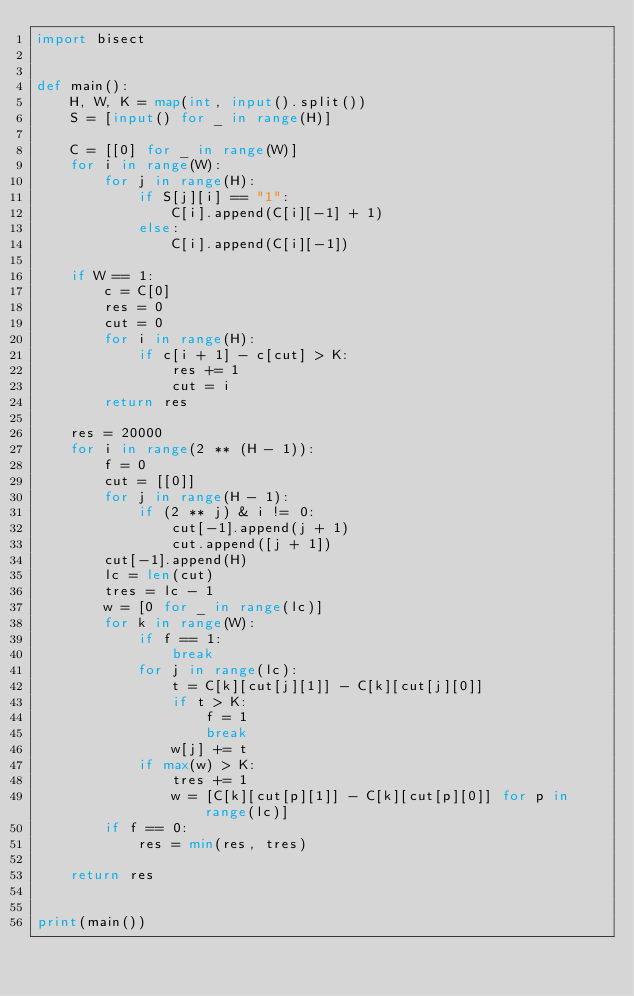<code> <loc_0><loc_0><loc_500><loc_500><_Python_>import bisect


def main():
    H, W, K = map(int, input().split())
    S = [input() for _ in range(H)]

    C = [[0] for _ in range(W)]
    for i in range(W):
        for j in range(H):
            if S[j][i] == "1":
                C[i].append(C[i][-1] + 1)
            else:
                C[i].append(C[i][-1])

    if W == 1:
        c = C[0]
        res = 0
        cut = 0
        for i in range(H):
            if c[i + 1] - c[cut] > K:
                res += 1
                cut = i
        return res

    res = 20000
    for i in range(2 ** (H - 1)):
        f = 0
        cut = [[0]]
        for j in range(H - 1):
            if (2 ** j) & i != 0:
                cut[-1].append(j + 1)
                cut.append([j + 1])
        cut[-1].append(H)
        lc = len(cut)
        tres = lc - 1
        w = [0 for _ in range(lc)]
        for k in range(W):
            if f == 1:
                break
            for j in range(lc):
                t = C[k][cut[j][1]] - C[k][cut[j][0]]
                if t > K:
                    f = 1
                    break
                w[j] += t
            if max(w) > K:
                tres += 1
                w = [C[k][cut[p][1]] - C[k][cut[p][0]] for p in range(lc)]
        if f == 0:
            res = min(res, tres)

    return res


print(main())
</code> 